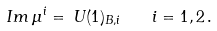<formula> <loc_0><loc_0><loc_500><loc_500>I m \, \mu ^ { i } = \, U ( 1 ) _ { B , i } \quad i = 1 , 2 \, .</formula> 